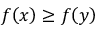Convert formula to latex. <formula><loc_0><loc_0><loc_500><loc_500>f \, \left ( x \right ) \geq f \, \left ( y \right )</formula> 